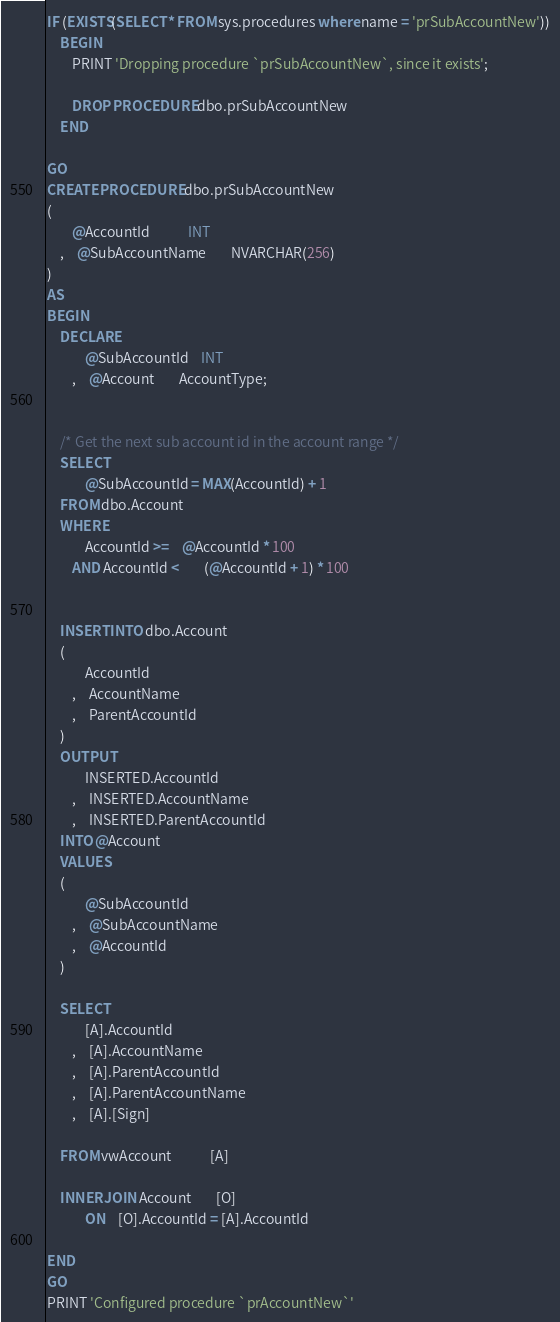<code> <loc_0><loc_0><loc_500><loc_500><_SQL_>
IF (EXISTS(SELECT * FROM sys.procedures where name = 'prSubAccountNew'))
	BEGIN
		PRINT 'Dropping procedure `prSubAccountNew`, since it exists';

		DROP PROCEDURE dbo.prSubAccountNew
	END

GO
CREATE PROCEDURE dbo.prSubAccountNew
(
		@AccountId			INT
	,	@SubAccountName		NVARCHAR(256)
)
AS
BEGIN
	DECLARE
			@SubAccountId	INT
		,	@Account		AccountType;


	/* Get the next sub account id in the account range */
	SELECT 
			@SubAccountId = MAX(AccountId) + 1
	FROM dbo.Account
	WHERE
			AccountId >=	@AccountId * 100
		AND AccountId <		(@AccountId + 1) * 100


	INSERT INTO dbo.Account 
	(
			AccountId
		,	AccountName
		,	ParentAccountId
	)
	OUTPUT 
			INSERTED.AccountId
		,	INSERTED.AccountName
		,	INSERTED.ParentAccountId
	INTO @Account
	VALUES 
	(
			@SubAccountId
		,	@SubAccountName
		,	@AccountId
	)

	SELECT
			[A].AccountId
		,	[A].AccountName
		,	[A].ParentAccountId
		,	[A].ParentAccountName
		,	[A].[Sign]

	FROM vwAccount			[A]

	INNER JOIN Account		[O]
			ON	[O].AccountId = [A].AccountId

END
GO
PRINT 'Configured procedure `prAccountNew`'
</code> 